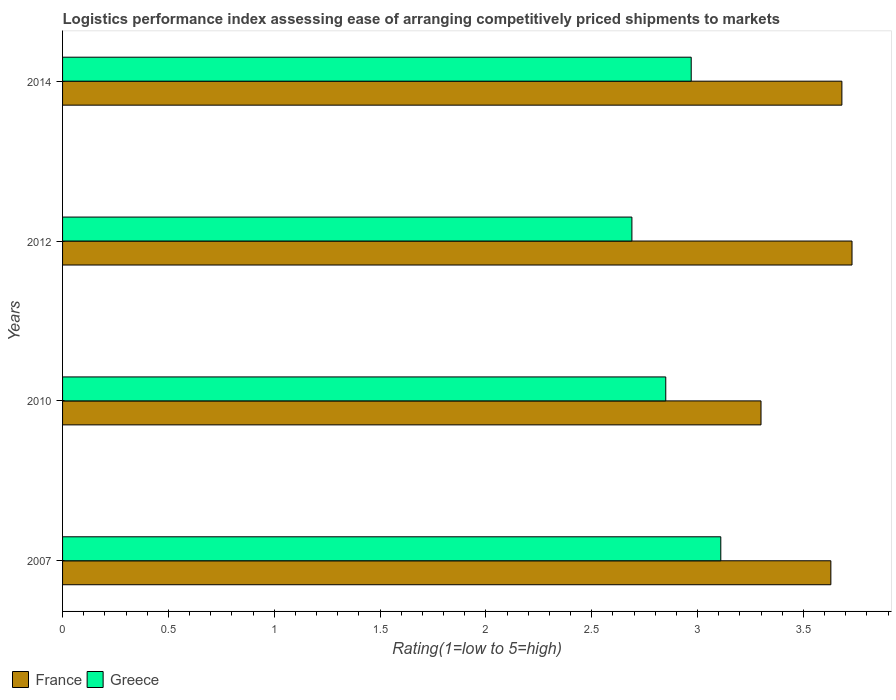Are the number of bars per tick equal to the number of legend labels?
Offer a very short reply. Yes. Are the number of bars on each tick of the Y-axis equal?
Offer a terse response. Yes. How many bars are there on the 1st tick from the top?
Ensure brevity in your answer.  2. What is the Logistic performance index in France in 2007?
Your response must be concise. 3.63. Across all years, what is the maximum Logistic performance index in Greece?
Your answer should be compact. 3.11. Across all years, what is the minimum Logistic performance index in France?
Offer a very short reply. 3.3. In which year was the Logistic performance index in Greece maximum?
Offer a very short reply. 2007. In which year was the Logistic performance index in France minimum?
Your answer should be very brief. 2010. What is the total Logistic performance index in Greece in the graph?
Ensure brevity in your answer.  11.62. What is the difference between the Logistic performance index in Greece in 2007 and that in 2010?
Your answer should be very brief. 0.26. What is the difference between the Logistic performance index in Greece in 2010 and the Logistic performance index in France in 2014?
Provide a succinct answer. -0.83. What is the average Logistic performance index in Greece per year?
Provide a succinct answer. 2.91. In the year 2007, what is the difference between the Logistic performance index in France and Logistic performance index in Greece?
Ensure brevity in your answer.  0.52. What is the ratio of the Logistic performance index in Greece in 2007 to that in 2014?
Your answer should be very brief. 1.05. Is the difference between the Logistic performance index in France in 2007 and 2010 greater than the difference between the Logistic performance index in Greece in 2007 and 2010?
Your response must be concise. Yes. What is the difference between the highest and the second highest Logistic performance index in France?
Keep it short and to the point. 0.05. What is the difference between the highest and the lowest Logistic performance index in France?
Provide a succinct answer. 0.43. In how many years, is the Logistic performance index in Greece greater than the average Logistic performance index in Greece taken over all years?
Your response must be concise. 2. Is the sum of the Logistic performance index in Greece in 2007 and 2012 greater than the maximum Logistic performance index in France across all years?
Your response must be concise. Yes. What does the 2nd bar from the top in 2014 represents?
Make the answer very short. France. What does the 2nd bar from the bottom in 2010 represents?
Make the answer very short. Greece. How many bars are there?
Your answer should be very brief. 8. Are all the bars in the graph horizontal?
Offer a very short reply. Yes. Are the values on the major ticks of X-axis written in scientific E-notation?
Offer a very short reply. No. Does the graph contain any zero values?
Provide a succinct answer. No. Where does the legend appear in the graph?
Make the answer very short. Bottom left. How many legend labels are there?
Your answer should be very brief. 2. How are the legend labels stacked?
Provide a succinct answer. Horizontal. What is the title of the graph?
Offer a terse response. Logistics performance index assessing ease of arranging competitively priced shipments to markets. Does "Iraq" appear as one of the legend labels in the graph?
Give a very brief answer. No. What is the label or title of the X-axis?
Your answer should be very brief. Rating(1=low to 5=high). What is the label or title of the Y-axis?
Keep it short and to the point. Years. What is the Rating(1=low to 5=high) in France in 2007?
Make the answer very short. 3.63. What is the Rating(1=low to 5=high) of Greece in 2007?
Your answer should be compact. 3.11. What is the Rating(1=low to 5=high) in France in 2010?
Your answer should be very brief. 3.3. What is the Rating(1=low to 5=high) in Greece in 2010?
Provide a succinct answer. 2.85. What is the Rating(1=low to 5=high) of France in 2012?
Provide a short and direct response. 3.73. What is the Rating(1=low to 5=high) in Greece in 2012?
Your response must be concise. 2.69. What is the Rating(1=low to 5=high) of France in 2014?
Your answer should be very brief. 3.68. What is the Rating(1=low to 5=high) of Greece in 2014?
Offer a terse response. 2.97. Across all years, what is the maximum Rating(1=low to 5=high) in France?
Your answer should be compact. 3.73. Across all years, what is the maximum Rating(1=low to 5=high) in Greece?
Give a very brief answer. 3.11. Across all years, what is the minimum Rating(1=low to 5=high) of Greece?
Keep it short and to the point. 2.69. What is the total Rating(1=low to 5=high) of France in the graph?
Give a very brief answer. 14.34. What is the total Rating(1=low to 5=high) in Greece in the graph?
Keep it short and to the point. 11.62. What is the difference between the Rating(1=low to 5=high) of France in 2007 and that in 2010?
Your answer should be very brief. 0.33. What is the difference between the Rating(1=low to 5=high) of Greece in 2007 and that in 2010?
Provide a succinct answer. 0.26. What is the difference between the Rating(1=low to 5=high) in France in 2007 and that in 2012?
Keep it short and to the point. -0.1. What is the difference between the Rating(1=low to 5=high) in Greece in 2007 and that in 2012?
Your answer should be very brief. 0.42. What is the difference between the Rating(1=low to 5=high) in France in 2007 and that in 2014?
Ensure brevity in your answer.  -0.05. What is the difference between the Rating(1=low to 5=high) of Greece in 2007 and that in 2014?
Offer a terse response. 0.14. What is the difference between the Rating(1=low to 5=high) in France in 2010 and that in 2012?
Keep it short and to the point. -0.43. What is the difference between the Rating(1=low to 5=high) in Greece in 2010 and that in 2012?
Provide a succinct answer. 0.16. What is the difference between the Rating(1=low to 5=high) of France in 2010 and that in 2014?
Provide a succinct answer. -0.38. What is the difference between the Rating(1=low to 5=high) in Greece in 2010 and that in 2014?
Give a very brief answer. -0.12. What is the difference between the Rating(1=low to 5=high) of France in 2012 and that in 2014?
Give a very brief answer. 0.05. What is the difference between the Rating(1=low to 5=high) in Greece in 2012 and that in 2014?
Your answer should be compact. -0.28. What is the difference between the Rating(1=low to 5=high) in France in 2007 and the Rating(1=low to 5=high) in Greece in 2010?
Offer a terse response. 0.78. What is the difference between the Rating(1=low to 5=high) of France in 2007 and the Rating(1=low to 5=high) of Greece in 2012?
Ensure brevity in your answer.  0.94. What is the difference between the Rating(1=low to 5=high) in France in 2007 and the Rating(1=low to 5=high) in Greece in 2014?
Provide a short and direct response. 0.66. What is the difference between the Rating(1=low to 5=high) in France in 2010 and the Rating(1=low to 5=high) in Greece in 2012?
Offer a terse response. 0.61. What is the difference between the Rating(1=low to 5=high) in France in 2010 and the Rating(1=low to 5=high) in Greece in 2014?
Give a very brief answer. 0.33. What is the difference between the Rating(1=low to 5=high) of France in 2012 and the Rating(1=low to 5=high) of Greece in 2014?
Your response must be concise. 0.76. What is the average Rating(1=low to 5=high) of France per year?
Ensure brevity in your answer.  3.59. What is the average Rating(1=low to 5=high) in Greece per year?
Your response must be concise. 2.91. In the year 2007, what is the difference between the Rating(1=low to 5=high) of France and Rating(1=low to 5=high) of Greece?
Keep it short and to the point. 0.52. In the year 2010, what is the difference between the Rating(1=low to 5=high) in France and Rating(1=low to 5=high) in Greece?
Keep it short and to the point. 0.45. In the year 2014, what is the difference between the Rating(1=low to 5=high) of France and Rating(1=low to 5=high) of Greece?
Your response must be concise. 0.71. What is the ratio of the Rating(1=low to 5=high) of France in 2007 to that in 2010?
Your answer should be compact. 1.1. What is the ratio of the Rating(1=low to 5=high) of Greece in 2007 to that in 2010?
Offer a very short reply. 1.09. What is the ratio of the Rating(1=low to 5=high) of France in 2007 to that in 2012?
Your answer should be compact. 0.97. What is the ratio of the Rating(1=low to 5=high) in Greece in 2007 to that in 2012?
Provide a succinct answer. 1.16. What is the ratio of the Rating(1=low to 5=high) of France in 2007 to that in 2014?
Your answer should be very brief. 0.99. What is the ratio of the Rating(1=low to 5=high) of Greece in 2007 to that in 2014?
Your answer should be very brief. 1.05. What is the ratio of the Rating(1=low to 5=high) of France in 2010 to that in 2012?
Ensure brevity in your answer.  0.88. What is the ratio of the Rating(1=low to 5=high) of Greece in 2010 to that in 2012?
Keep it short and to the point. 1.06. What is the ratio of the Rating(1=low to 5=high) of France in 2010 to that in 2014?
Offer a terse response. 0.9. What is the ratio of the Rating(1=low to 5=high) of Greece in 2010 to that in 2014?
Provide a short and direct response. 0.96. What is the ratio of the Rating(1=low to 5=high) in Greece in 2012 to that in 2014?
Your answer should be compact. 0.91. What is the difference between the highest and the second highest Rating(1=low to 5=high) in France?
Offer a very short reply. 0.05. What is the difference between the highest and the second highest Rating(1=low to 5=high) in Greece?
Provide a succinct answer. 0.14. What is the difference between the highest and the lowest Rating(1=low to 5=high) in France?
Ensure brevity in your answer.  0.43. What is the difference between the highest and the lowest Rating(1=low to 5=high) of Greece?
Your response must be concise. 0.42. 